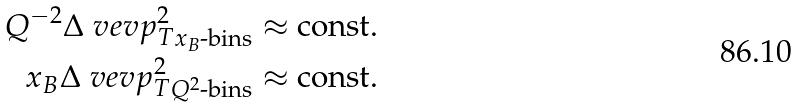<formula> <loc_0><loc_0><loc_500><loc_500>Q ^ { - 2 } \Delta \ v e v { p _ { T } ^ { 2 } } _ { x _ { B } \text {-bins} } \approx \text {const.} \\ x _ { B } \Delta \ v e v { p _ { T } ^ { 2 } } _ { Q ^ { 2 } \text {-bins} } \approx \text {const.}</formula> 